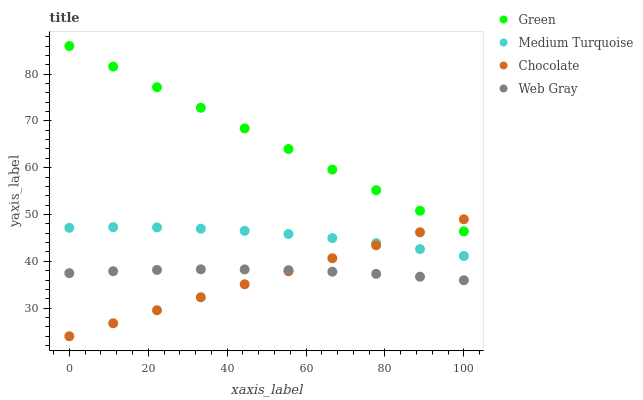Does Chocolate have the minimum area under the curve?
Answer yes or no. Yes. Does Green have the maximum area under the curve?
Answer yes or no. Yes. Does Medium Turquoise have the minimum area under the curve?
Answer yes or no. No. Does Medium Turquoise have the maximum area under the curve?
Answer yes or no. No. Is Chocolate the smoothest?
Answer yes or no. Yes. Is Medium Turquoise the roughest?
Answer yes or no. Yes. Is Green the smoothest?
Answer yes or no. No. Is Green the roughest?
Answer yes or no. No. Does Chocolate have the lowest value?
Answer yes or no. Yes. Does Medium Turquoise have the lowest value?
Answer yes or no. No. Does Green have the highest value?
Answer yes or no. Yes. Does Medium Turquoise have the highest value?
Answer yes or no. No. Is Web Gray less than Green?
Answer yes or no. Yes. Is Green greater than Medium Turquoise?
Answer yes or no. Yes. Does Web Gray intersect Chocolate?
Answer yes or no. Yes. Is Web Gray less than Chocolate?
Answer yes or no. No. Is Web Gray greater than Chocolate?
Answer yes or no. No. Does Web Gray intersect Green?
Answer yes or no. No. 